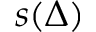<formula> <loc_0><loc_0><loc_500><loc_500>s ( \Delta )</formula> 